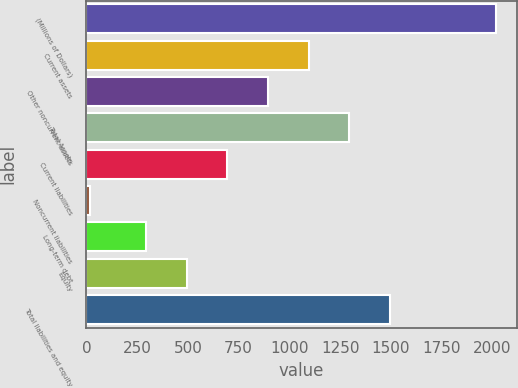<chart> <loc_0><loc_0><loc_500><loc_500><bar_chart><fcel>(Millions of Dollars)<fcel>Current assets<fcel>Other noncurrent assets<fcel>Total Assets<fcel>Current liabilities<fcel>Noncurrent liabilities<fcel>Long-term debt<fcel>Equity<fcel>Total liabilities and equity<nl><fcel>2017<fcel>1094.6<fcel>894.7<fcel>1294.5<fcel>694.8<fcel>18<fcel>295<fcel>494.9<fcel>1494.4<nl></chart> 